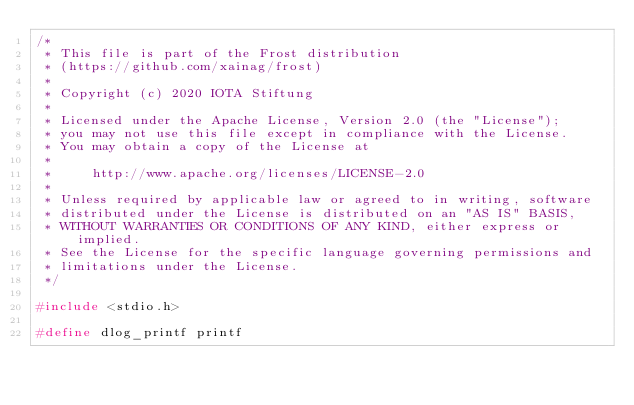Convert code to text. <code><loc_0><loc_0><loc_500><loc_500><_C_>/*
 * This file is part of the Frost distribution
 * (https://github.com/xainag/frost)
 *
 * Copyright (c) 2020 IOTA Stiftung
 *
 * Licensed under the Apache License, Version 2.0 (the "License");
 * you may not use this file except in compliance with the License.
 * You may obtain a copy of the License at
 *
 *     http://www.apache.org/licenses/LICENSE-2.0
 *
 * Unless required by applicable law or agreed to in writing, software
 * distributed under the License is distributed on an "AS IS" BASIS,
 * WITHOUT WARRANTIES OR CONDITIONS OF ANY KIND, either express or implied.
 * See the License for the specific language governing permissions and
 * limitations under the License.
 */

#include <stdio.h>

#define dlog_printf printf
</code> 